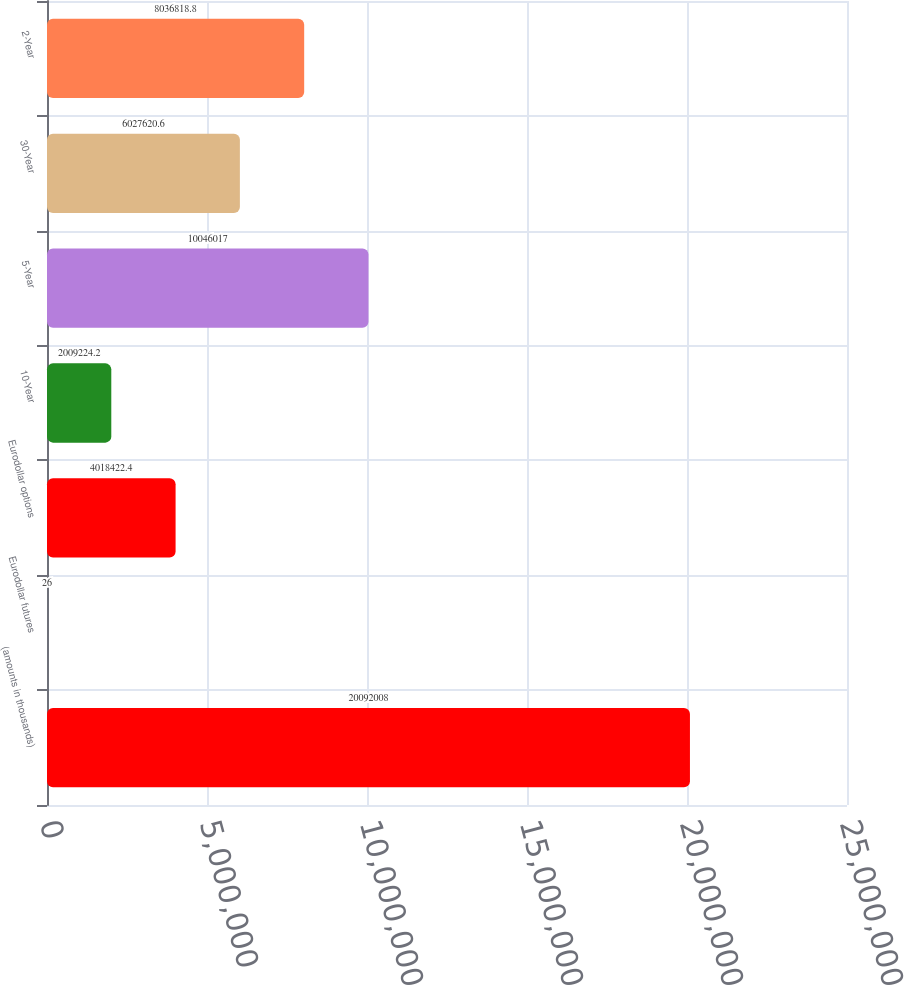Convert chart to OTSL. <chart><loc_0><loc_0><loc_500><loc_500><bar_chart><fcel>(amounts in thousands)<fcel>Eurodollar futures<fcel>Eurodollar options<fcel>10-Year<fcel>5-Year<fcel>30-Year<fcel>2-Year<nl><fcel>2.0092e+07<fcel>26<fcel>4.01842e+06<fcel>2.00922e+06<fcel>1.0046e+07<fcel>6.02762e+06<fcel>8.03682e+06<nl></chart> 